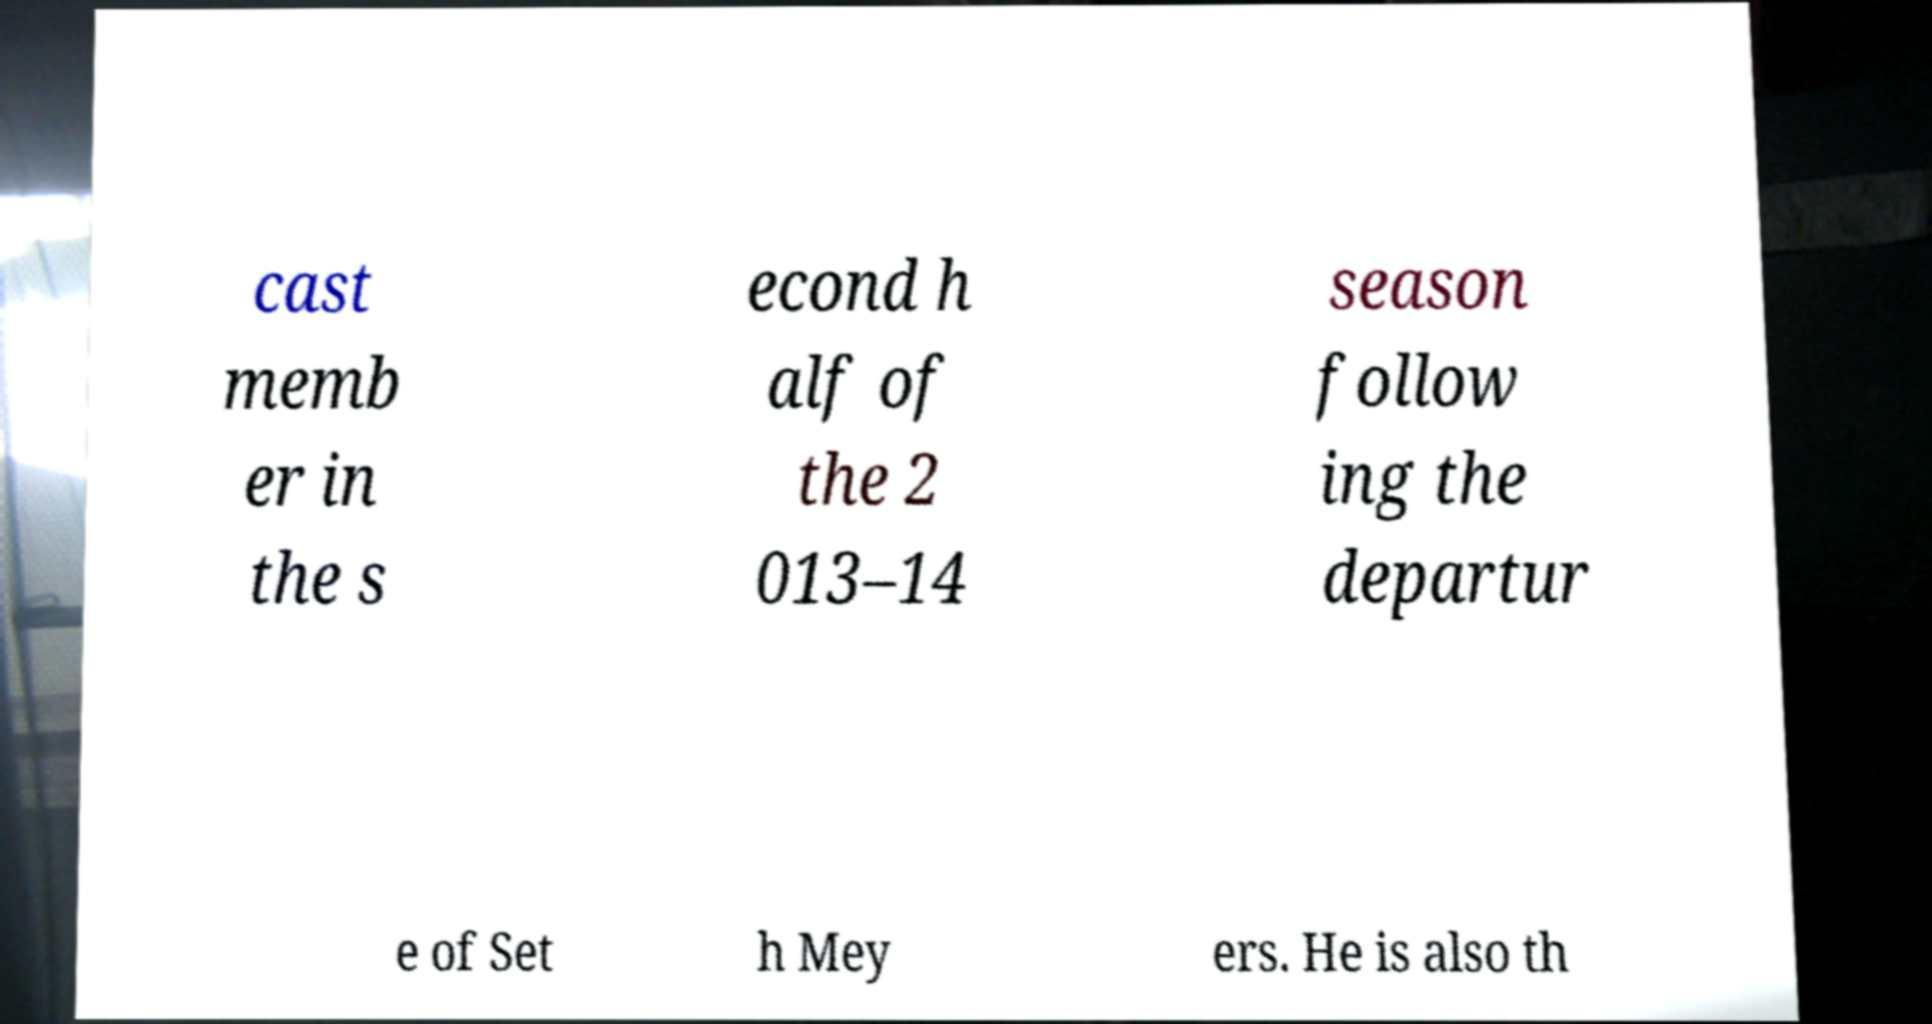Could you assist in decoding the text presented in this image and type it out clearly? cast memb er in the s econd h alf of the 2 013–14 season follow ing the departur e of Set h Mey ers. He is also th 